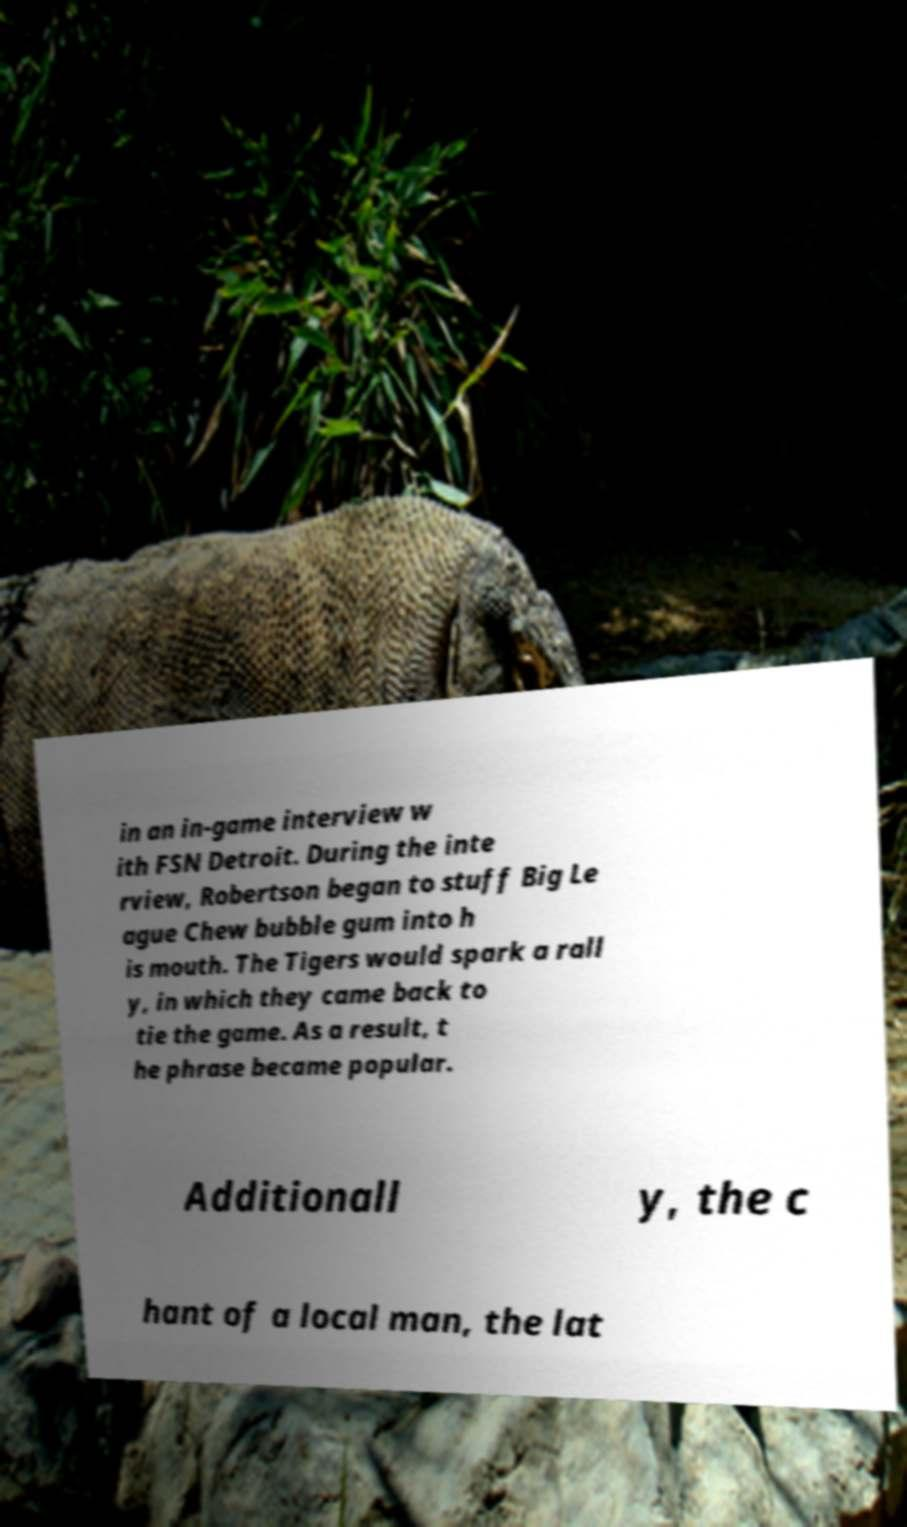Could you extract and type out the text from this image? in an in-game interview w ith FSN Detroit. During the inte rview, Robertson began to stuff Big Le ague Chew bubble gum into h is mouth. The Tigers would spark a rall y, in which they came back to tie the game. As a result, t he phrase became popular. Additionall y, the c hant of a local man, the lat 